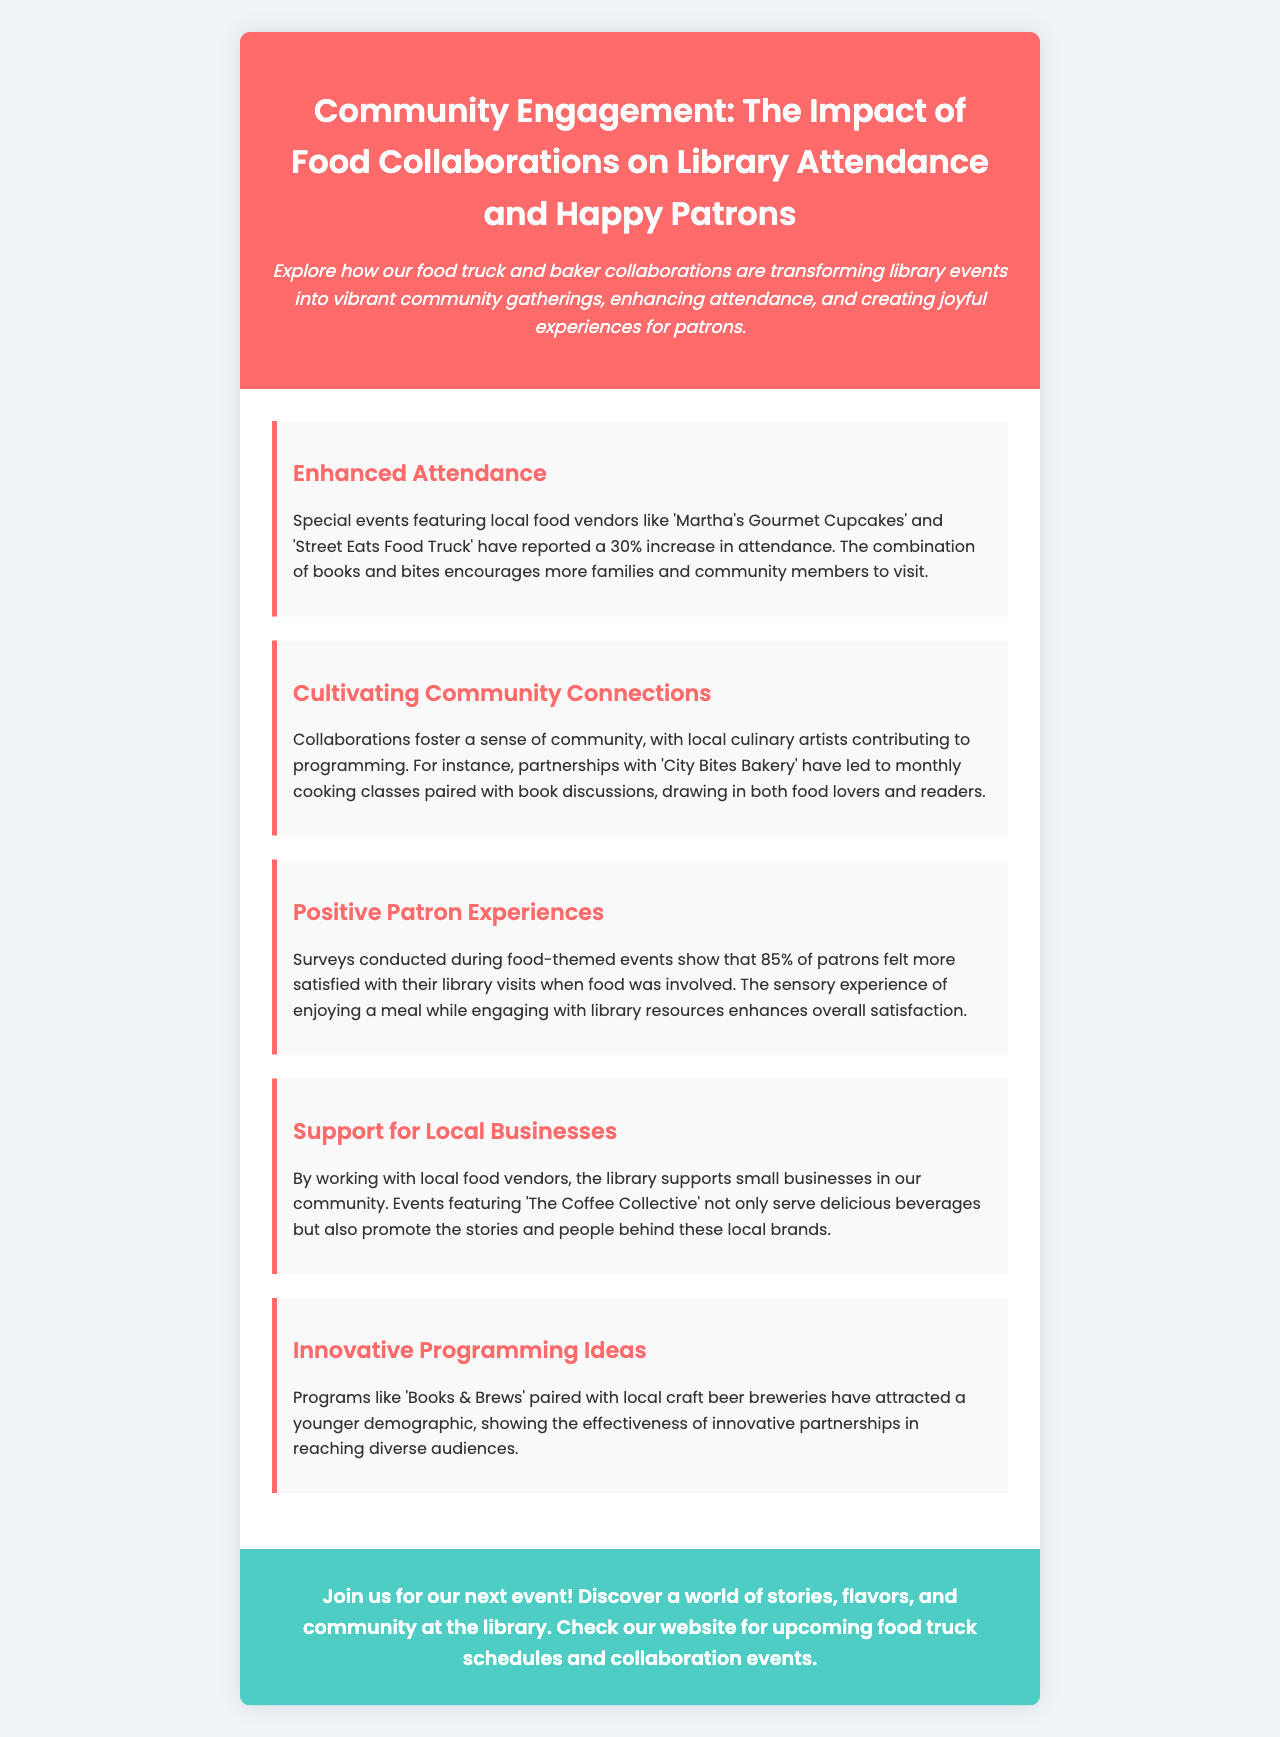What is the title of the brochure? The title is found in the header section of the document, which states the focus of the brochure.
Answer: Community Engagement: The Impact of Food Collaborations on Library Attendance and Happy Patrons What percentage increase in attendance is reported? The document specifies the impact of food collaborations on attendance, providing a clear statistic.
Answer: 30% Which bakery is mentioned as a collaborator? The document prominently features 'Martha's Gourmet Cupcakes' as an example of a local vendor involved in events.
Answer: Martha's Gourmet Cupcakes What percentage of patrons felt more satisfied with their library visits when food was included? A specific finding from surveys is detailed in the document, reflecting patron satisfaction levels.
Answer: 85% What is one example of an innovative program mentioned? The brochure lists a specific program that pairs literature and beverages, showcasing creativity in library events.
Answer: Books & Brews How do collaborations support local businesses? The document describes how these partnerships benefit small businesses in the community, highlighting the library’s role.
Answer: Promotes stories and people behind local brands What type of classes have been led by 'City Bites Bakery'? The collaborative efforts with this bakery are described, indicating the kind of educational programming provided.
Answer: Cooking classes Who is encouraged to join future events? The brochure's call to action invites a specific audience to attend library events connected with food vendors.
Answer: Community members 